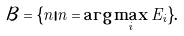Convert formula to latex. <formula><loc_0><loc_0><loc_500><loc_500>\mathcal { B } = \{ n | n = \arg \max _ { i } E _ { i } \} .</formula> 